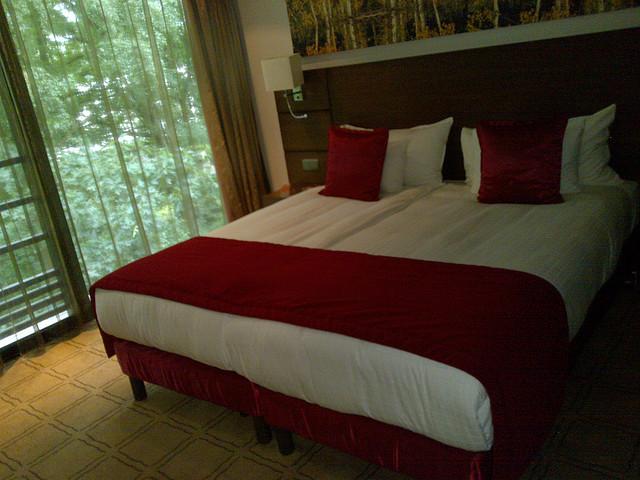What is the cat lying on?
Short answer required. Bed. How old is this blanket?
Write a very short answer. New. Where are the pillows?
Short answer required. On bed. What color is the bedskirt?
Give a very brief answer. Red. What type of pattern can be found on the folded blanket?
Concise answer only. Solid. Are the curtains dark?
Keep it brief. No. How many pillows are in this room?
Short answer required. 6. Are these string lights over the headboard?
Quick response, please. No. What color is the blanket at the foot of the bed?
Keep it brief. Red. What size bed is this?
Quick response, please. King. What type of material is the bed frame made from?
Quick response, please. Wood. Is the room dirty?
Write a very short answer. No. Are both pillows the same color?
Short answer required. Yes. What kind of floor is this?
Be succinct. Tile. What two colors compose the complementary color scheme?
Write a very short answer. Red and white. 